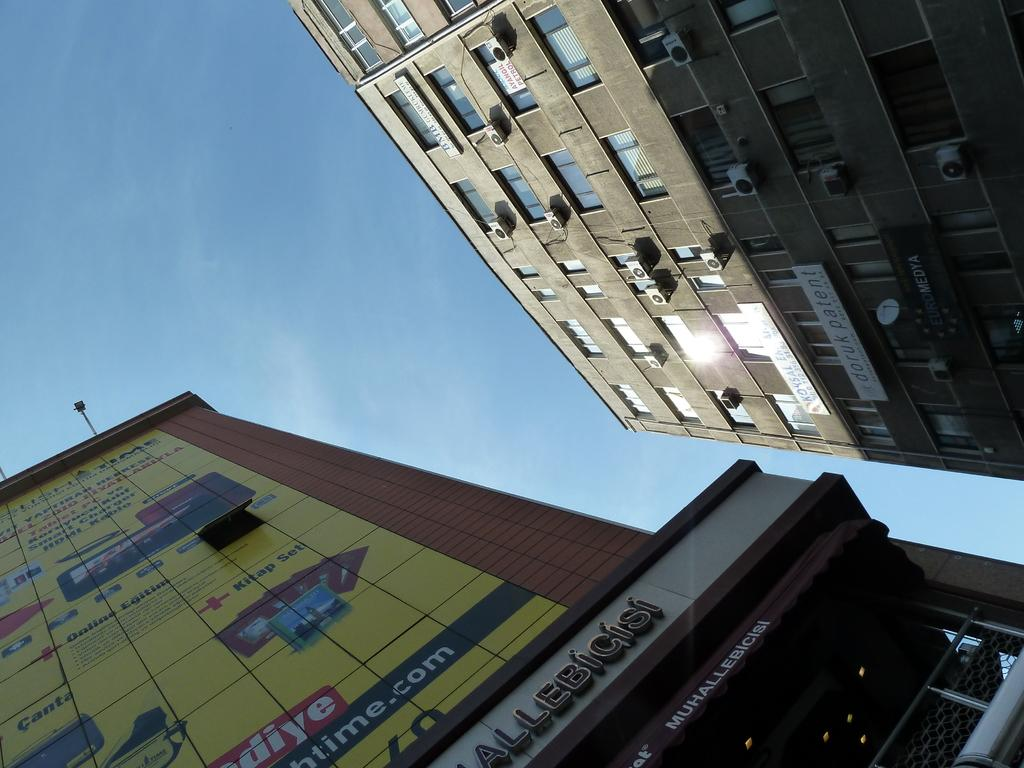What type of structures can be seen in the image? There are buildings in the image. What is visible at the top of the image? The sky is visible at the top of the image. Can you see any ghosts interacting with the buildings in the image? There are no ghosts present in the image; it only features buildings and the sky. What type of account is associated with the buildings in the image? There is no mention of any account related to the buildings in the image. 